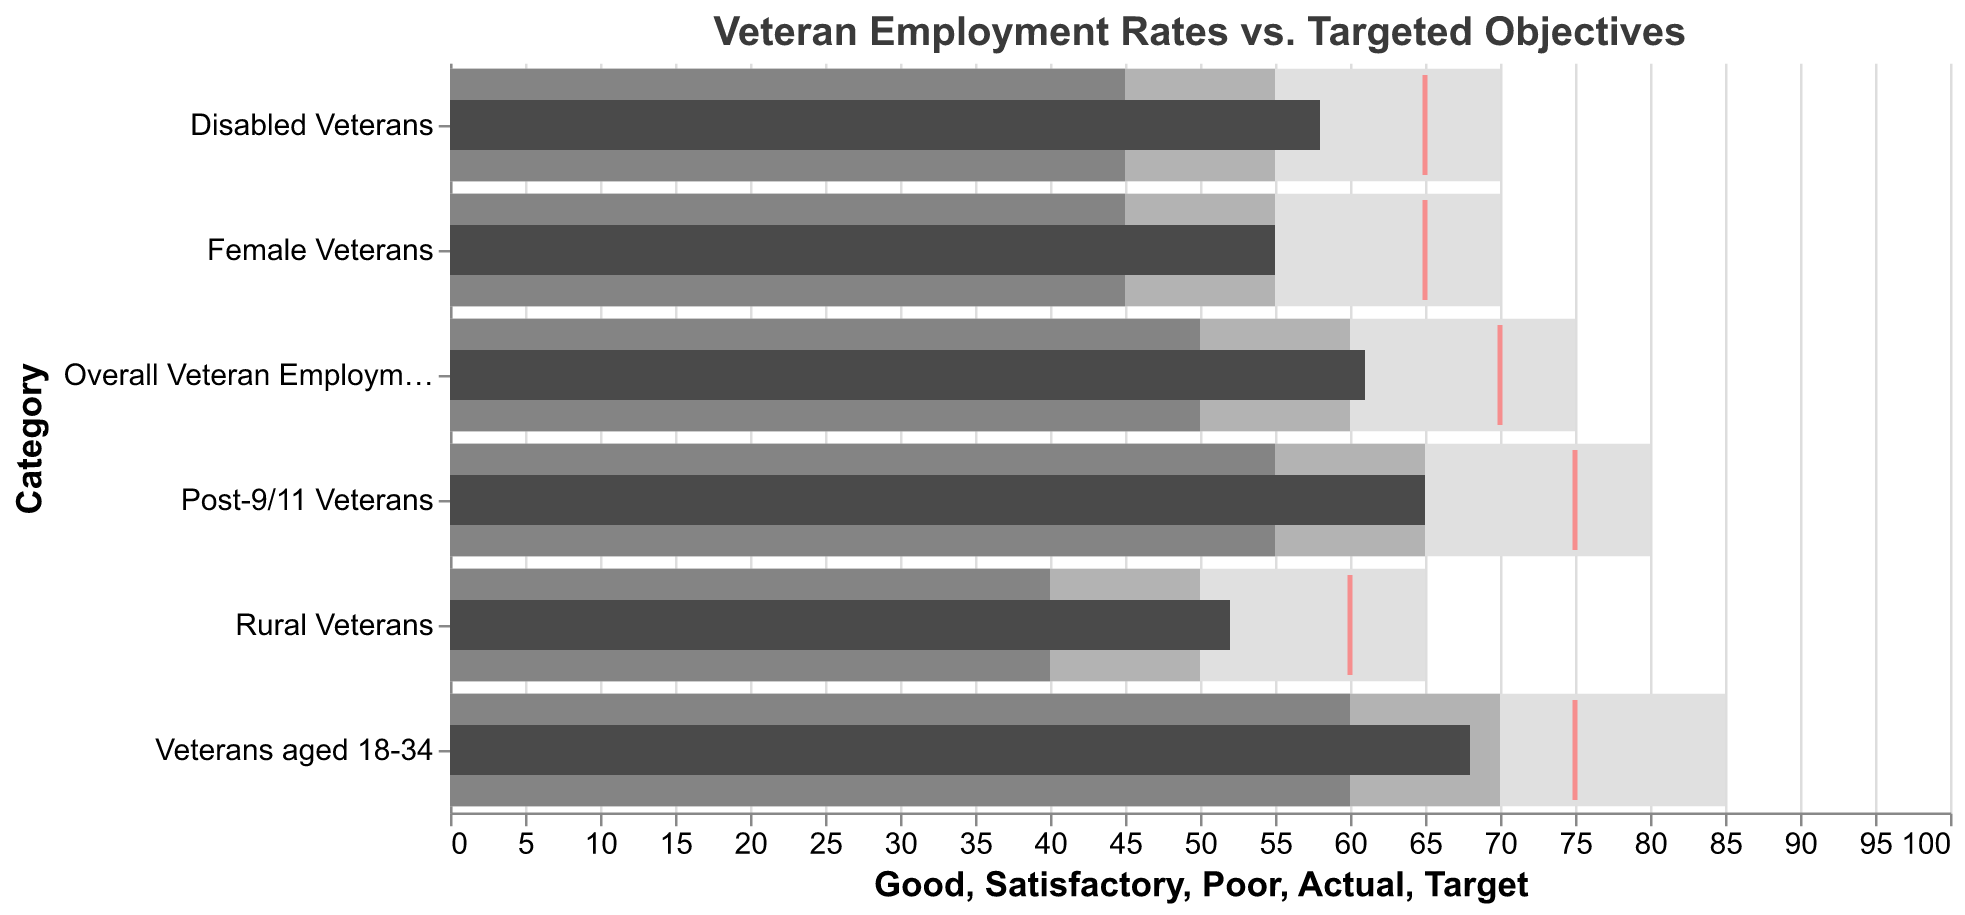What is the title of the chart? The title is displayed at the top center of the chart. It reads "Veteran Employment Rates vs. Targeted Objectives" in a 16-point Arial font.
Answer: Veteran Employment Rates vs. Targeted Objectives What color is used to represent the "Target" value in the chart? The "Target" value is shown as a tick mark. It is colored in bright red.
Answer: red What is the actual employment rate for Female Veterans? The chart has a bar for each category labeled with its actual employment rate. For Female Veterans, the bar ends at 55.
Answer: 55 Which category has the highest target employment rate? The chart has tick marks representing target rates. "Veterans aged 18-34" has the highest target rate with the tick mark at 75.
Answer: Veterans aged 18-34 By how much does the actual employment rate for Overall Veteran Employment fall short of the target? The "Actual" bar for Overall Veteran Employment is at 61, and the "Target" tick mark is at 70. The difference is 70 - 61 = 9.
Answer: 9 Which veteran group has the lowest actual employment rate? The bars labeled "Actual" indicate the employment rates. "Rural Veterans" has the lowest actual rate at 52.
Answer: Rural Veterans What is the range for a Satisfactory employment rate for Disabled Veterans? The middle shaded bar represents the Satisfactory range. For Disabled Veterans, it extends from 55 to 65.
Answer: 55 to 65 How do the actual employment rates for Female Veterans and Disabled Veterans compare? Which is higher? Comparing the heights of the bars labeled "Actual," Disabled Veterans have a slightly higher employment rate at 58 compared to Female Veterans at 55.
Answer: Disabled Veterans Are there any groups where the actual employment rate meets or exceeds the satisfactory level? Looking at the "Actual" bars and comparing them to the satisfactory range: "Post-9/11 Veterans" and "Veterans aged 18-34" achieve this, as their actual rates meet or exceed the lower boundary of the satisfactory range.
Answer: Yes, Post-9/11 Veterans and Veterans aged 18-34 What is the difference between the good employment rate threshold and the actual employment rate for Rural Veterans? The "Good" threshold for Rural Veterans is represented at 65. The actual rate is 52, so the difference is 65 - 52 = 13.
Answer: 13 